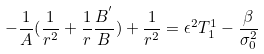Convert formula to latex. <formula><loc_0><loc_0><loc_500><loc_500>- \frac { 1 } { A } ( \frac { 1 } { r ^ { 2 } } + \frac { 1 } { r } \frac { B ^ { ^ { \prime } } } { B } ) + \frac { 1 } { r ^ { 2 } } = \epsilon ^ { 2 } T _ { 1 } ^ { 1 } - \frac { \beta } { \sigma _ { 0 } ^ { 2 } }</formula> 